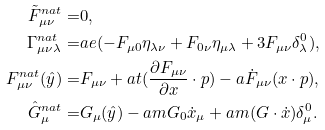Convert formula to latex. <formula><loc_0><loc_0><loc_500><loc_500>\tilde { F } _ { \mu \nu } ^ { n a t } = & 0 , \\ \Gamma _ { \mu \nu \lambda } ^ { n a t } = & a e ( - F _ { \mu 0 } \eta _ { \lambda \nu } + F _ { 0 \nu } \eta _ { \mu \lambda } + 3 F _ { \mu \nu } \delta _ { \lambda } ^ { 0 } ) , \\ F _ { \mu \nu } ^ { n a t } ( \hat { y } ) = & F _ { \mu \nu } + a t ( \frac { \partial F _ { \mu \nu } } { \partial x } \cdot p ) - a \dot { F } _ { \mu \nu } ( x \cdot p ) , \\ \hat { G } _ { \mu } ^ { n a t } = & G _ { \mu } ( \hat { y } ) - a m G _ { 0 } \dot { x } _ { \mu } + a m ( G \cdot \dot { x } ) \delta _ { \mu } ^ { 0 } . \\</formula> 